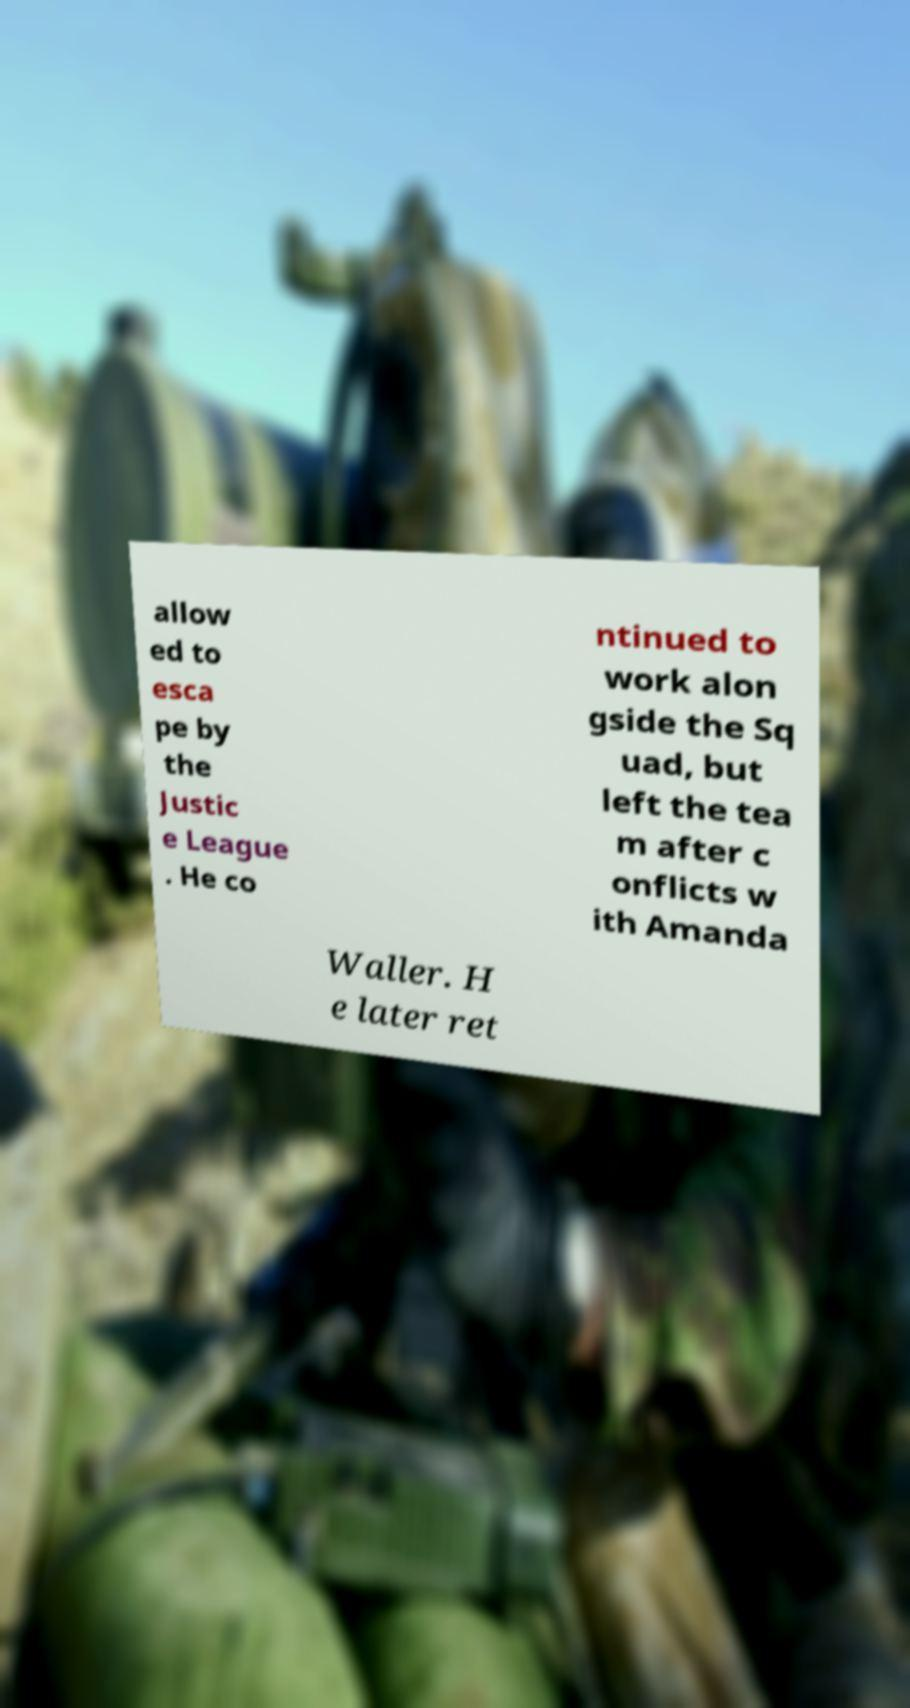Could you extract and type out the text from this image? allow ed to esca pe by the Justic e League . He co ntinued to work alon gside the Sq uad, but left the tea m after c onflicts w ith Amanda Waller. H e later ret 